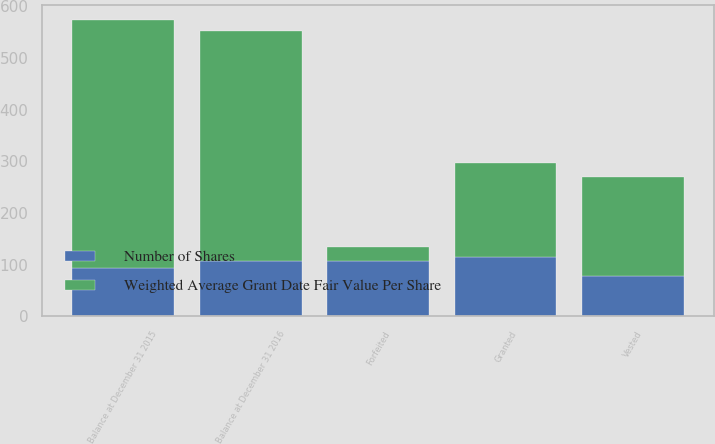Convert chart. <chart><loc_0><loc_0><loc_500><loc_500><stacked_bar_chart><ecel><fcel>Balance at December 31 2015<fcel>Granted<fcel>Vested<fcel>Forfeited<fcel>Balance at December 31 2016<nl><fcel>Weighted Average Grant Date Fair Value Per Share<fcel>480<fcel>183<fcel>192<fcel>27<fcel>444<nl><fcel>Number of Shares<fcel>93.33<fcel>113.76<fcel>78.44<fcel>106.62<fcel>107.43<nl></chart> 